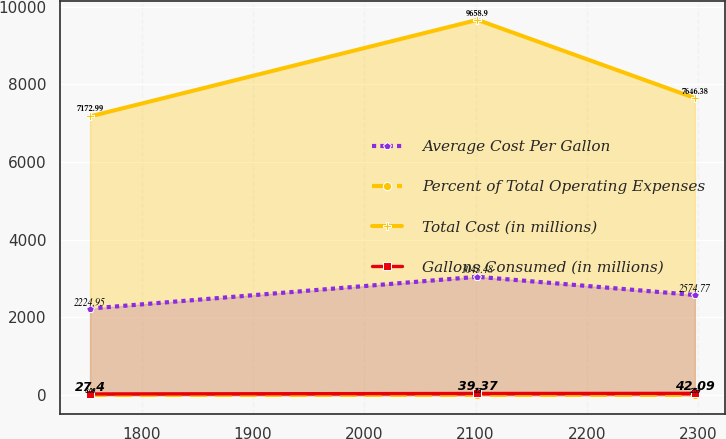<chart> <loc_0><loc_0><loc_500><loc_500><line_chart><ecel><fcel>Average Cost Per Gallon<fcel>Percent of Total Operating Expenses<fcel>Total Cost (in millions)<fcel>Gallons Consumed (in millions)<nl><fcel>1753.7<fcel>2224.95<fcel>3.08<fcel>7172.99<fcel>27.4<nl><fcel>2101.68<fcel>3043.48<fcel>3.3<fcel>9658.9<fcel>39.37<nl><fcel>2296.94<fcel>2574.77<fcel>2.59<fcel>7646.38<fcel>42.09<nl></chart> 